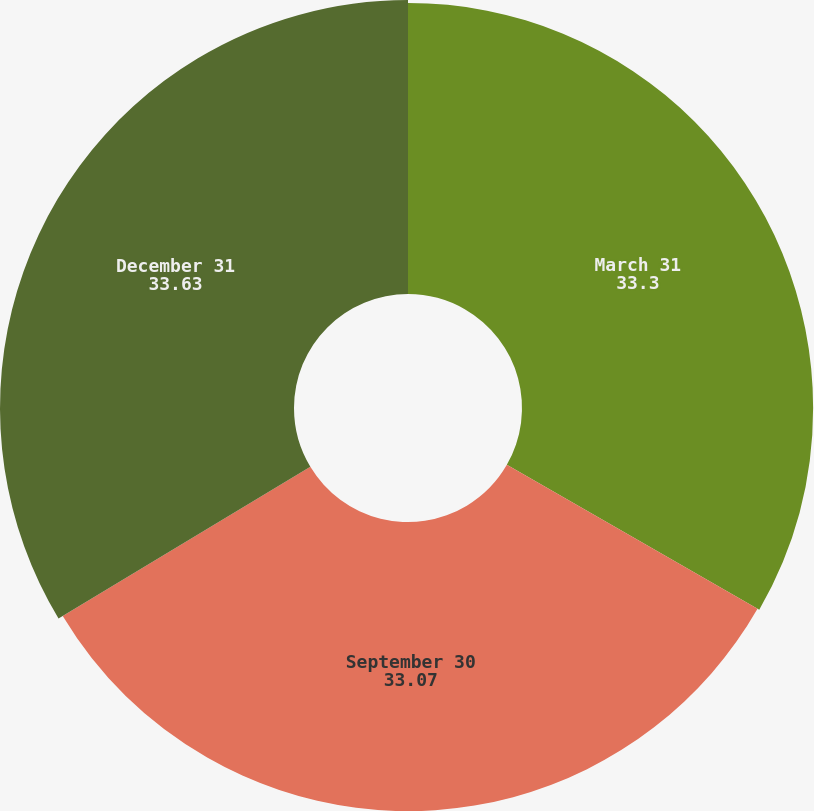<chart> <loc_0><loc_0><loc_500><loc_500><pie_chart><fcel>March 31<fcel>September 30<fcel>December 31<nl><fcel>33.3%<fcel>33.07%<fcel>33.63%<nl></chart> 